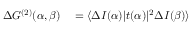Convert formula to latex. <formula><loc_0><loc_0><loc_500><loc_500>\begin{array} { r l } { \Delta G ^ { ( 2 ) } ( \alpha , \beta ) } & = \langle \Delta I ( \alpha ) | t ( \alpha ) | ^ { 2 } \Delta I ( \beta ) \rangle } \end{array}</formula> 